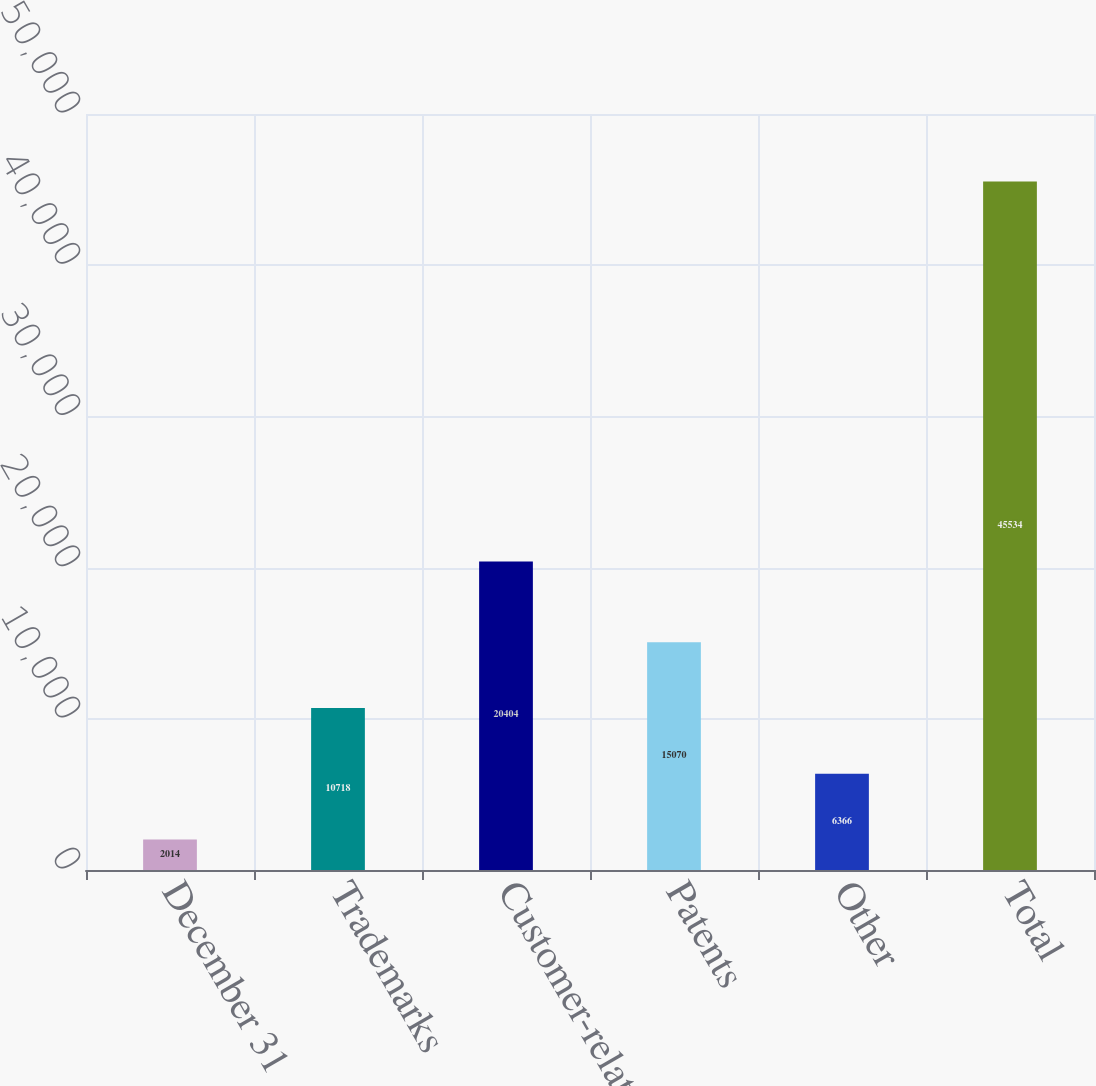Convert chart. <chart><loc_0><loc_0><loc_500><loc_500><bar_chart><fcel>December 31<fcel>Trademarks<fcel>Customer-related<fcel>Patents<fcel>Other<fcel>Total<nl><fcel>2014<fcel>10718<fcel>20404<fcel>15070<fcel>6366<fcel>45534<nl></chart> 